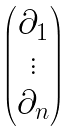<formula> <loc_0><loc_0><loc_500><loc_500>\begin{pmatrix} \partial _ { 1 } \\ \vdots \\ \partial _ { n } \end{pmatrix}</formula> 